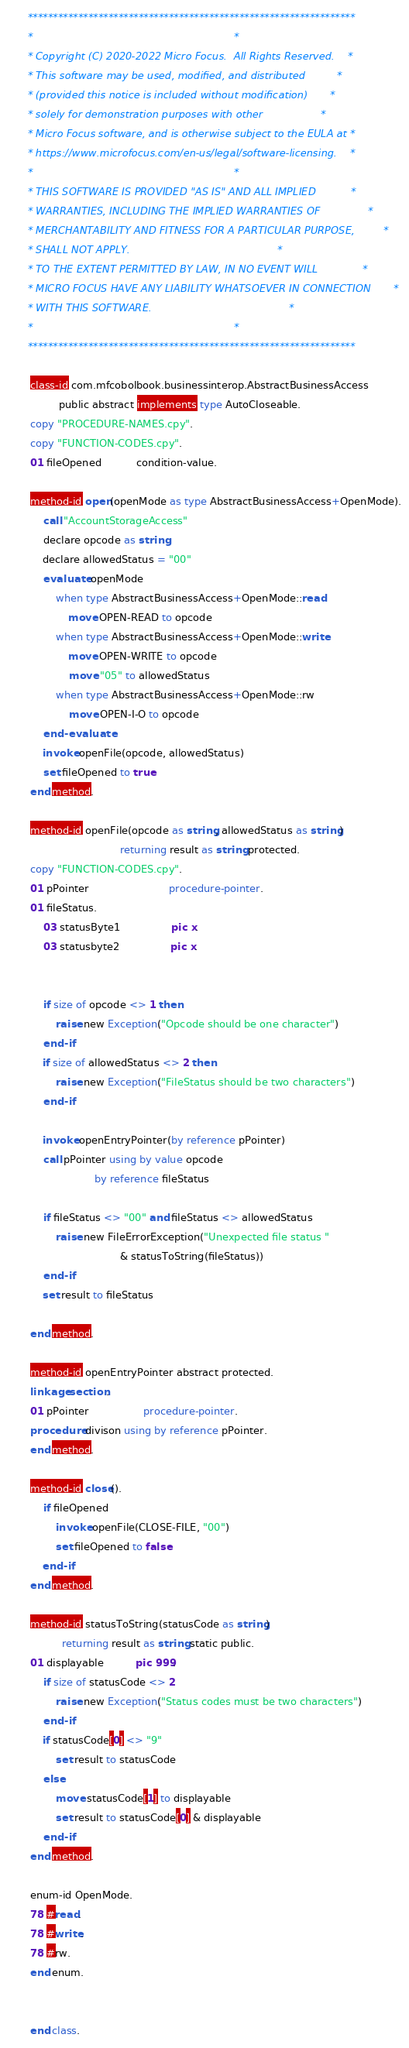Convert code to text. <code><loc_0><loc_0><loc_500><loc_500><_COBOL_>      *****************************************************************
      *                                                               *
      * Copyright (C) 2020-2022 Micro Focus.  All Rights Reserved.    *
      * This software may be used, modified, and distributed          *
      * (provided this notice is included without modification)       *
      * solely for demonstration purposes with other                  *
      * Micro Focus software, and is otherwise subject to the EULA at *
      * https://www.microfocus.com/en-us/legal/software-licensing.    *
      *                                                               *
      * THIS SOFTWARE IS PROVIDED "AS IS" AND ALL IMPLIED           *
      * WARRANTIES, INCLUDING THE IMPLIED WARRANTIES OF               *
      * MERCHANTABILITY AND FITNESS FOR A PARTICULAR PURPOSE,         *
      * SHALL NOT APPLY.                                              *
      * TO THE EXTENT PERMITTED BY LAW, IN NO EVENT WILL              *
      * MICRO FOCUS HAVE ANY LIABILITY WHATSOEVER IN CONNECTION       *
      * WITH THIS SOFTWARE.                                           *
      *                                                               *
      *****************************************************************
      
       class-id com.mfcobolbook.businessinterop.AbstractBusinessAccess 
                public abstract implements type AutoCloseable.
       copy "PROCEDURE-NAMES.cpy". 
       copy "FUNCTION-CODES.cpy". 
       01 fileOpened           condition-value. 

       method-id open(openMode as type AbstractBusinessAccess+OpenMode).
           call "AccountStorageAccess" 
           declare opcode as string
           declare allowedStatus = "00"
           evaluate openMode
               when type AbstractBusinessAccess+OpenMode::read
                   move OPEN-READ to opcode
               when type AbstractBusinessAccess+OpenMode::write
                   move OPEN-WRITE to opcode
                   move "05" to allowedStatus
               when type AbstractBusinessAccess+OpenMode::rw
                   move OPEN-I-O to opcode
           end-evaluate
           invoke openFile(opcode, allowedStatus)
           set fileOpened to true
       end method. 
       
       method-id openFile(opcode as string, allowedStatus as string)
                                   returning result as string protected.
       copy "FUNCTION-CODES.cpy". 
       01 pPointer                         procedure-pointer.
       01 fileStatus.
           03 statusByte1                pic x.
           03 statusbyte2                pic x. 
           
       
           if size of opcode <> 1 then
               raise new Exception("Opcode should be one character")
           end-if
           if size of allowedStatus <> 2 then 
               raise new Exception("FileStatus should be two characters")
           end-if
           
           invoke openEntryPointer(by reference pPointer)   
           call pPointer using by value opcode 
                           by reference fileStatus
       
           if fileStatus <> "00" and fileStatus <> allowedStatus
               raise new FileErrorException("Unexpected file status " 
                                   & statusToString(fileStatus))
           end-if
           set result to fileStatus
       
       end method.
       
       method-id openEntryPointer abstract protected.
       linkage section. 
       01 pPointer                 procedure-pointer.
       procedure divison using by reference pPointer.
       end method.  

       method-id close(). 
           if fileOpened
               invoke openFile(CLOSE-FILE, "00")
               set fileOpened to false
           end-if
       end method.
       
       method-id statusToString(statusCode as string) 
                 returning result as string static public.
       01 displayable          pic 999. 
           if size of statusCode <> 2
               raise new Exception("Status codes must be two characters")
           end-if
           if statusCode[0] <> "9"
               set result to statusCode
           else
               move statusCode[1] to displayable   
               set result to statusCode[0] & displayable
           end-if
       end method. 
       
       enum-id OpenMode.
       78 #read.
       78 #write.
       78 #rw.  
       end enum. 

       
       end class.
</code> 